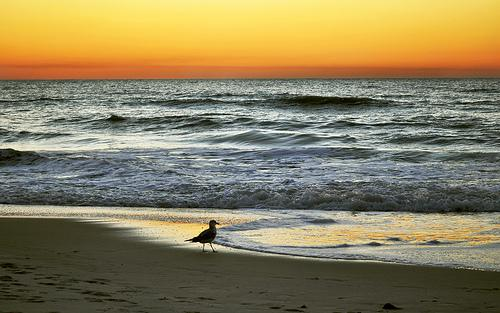Question: who is next to the bird?
Choices:
A. I am.
B. No one.
C. She is.
D. They are.
Answer with the letter. Answer: B Question: when was the photo taken?
Choices:
A. Afternoon.
B. Morning.
C. Dawn.
D. Evening.
Answer with the letter. Answer: D Question: where was the photo taken?
Choices:
A. In a boat.
B. At work.
C. At a game.
D. On a beach.
Answer with the letter. Answer: D 